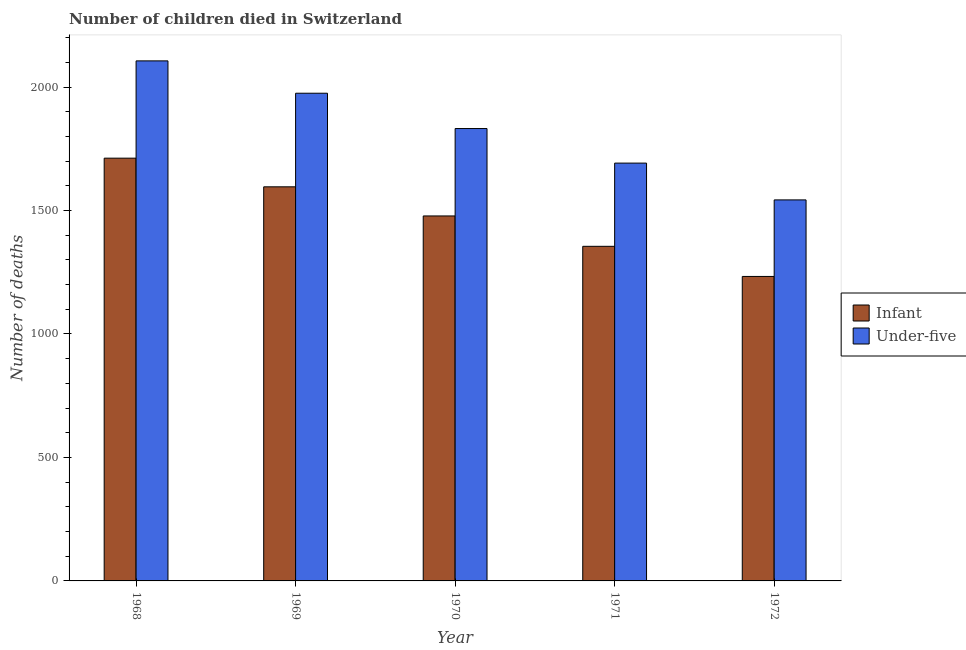How many different coloured bars are there?
Your answer should be very brief. 2. How many groups of bars are there?
Your response must be concise. 5. Are the number of bars per tick equal to the number of legend labels?
Ensure brevity in your answer.  Yes. Are the number of bars on each tick of the X-axis equal?
Keep it short and to the point. Yes. How many bars are there on the 1st tick from the left?
Your answer should be compact. 2. What is the number of infant deaths in 1969?
Offer a terse response. 1596. Across all years, what is the maximum number of under-five deaths?
Your answer should be compact. 2106. Across all years, what is the minimum number of under-five deaths?
Your answer should be very brief. 1543. In which year was the number of under-five deaths maximum?
Provide a succinct answer. 1968. What is the total number of under-five deaths in the graph?
Offer a very short reply. 9148. What is the difference between the number of infant deaths in 1968 and that in 1971?
Make the answer very short. 357. What is the difference between the number of under-five deaths in 1969 and the number of infant deaths in 1968?
Your answer should be compact. -131. What is the average number of under-five deaths per year?
Provide a short and direct response. 1829.6. What is the ratio of the number of under-five deaths in 1969 to that in 1970?
Keep it short and to the point. 1.08. What is the difference between the highest and the second highest number of infant deaths?
Your response must be concise. 116. What is the difference between the highest and the lowest number of infant deaths?
Give a very brief answer. 479. Is the sum of the number of under-five deaths in 1970 and 1972 greater than the maximum number of infant deaths across all years?
Make the answer very short. Yes. What does the 1st bar from the left in 1969 represents?
Your response must be concise. Infant. What does the 1st bar from the right in 1969 represents?
Your answer should be compact. Under-five. How many bars are there?
Ensure brevity in your answer.  10. Are all the bars in the graph horizontal?
Make the answer very short. No. How many years are there in the graph?
Provide a succinct answer. 5. What is the difference between two consecutive major ticks on the Y-axis?
Your answer should be compact. 500. Are the values on the major ticks of Y-axis written in scientific E-notation?
Offer a terse response. No. Does the graph contain grids?
Your answer should be compact. No. Where does the legend appear in the graph?
Your answer should be very brief. Center right. How are the legend labels stacked?
Make the answer very short. Vertical. What is the title of the graph?
Your answer should be very brief. Number of children died in Switzerland. Does "IMF nonconcessional" appear as one of the legend labels in the graph?
Make the answer very short. No. What is the label or title of the Y-axis?
Keep it short and to the point. Number of deaths. What is the Number of deaths in Infant in 1968?
Your answer should be very brief. 1712. What is the Number of deaths of Under-five in 1968?
Make the answer very short. 2106. What is the Number of deaths in Infant in 1969?
Make the answer very short. 1596. What is the Number of deaths in Under-five in 1969?
Your response must be concise. 1975. What is the Number of deaths in Infant in 1970?
Your response must be concise. 1478. What is the Number of deaths of Under-five in 1970?
Make the answer very short. 1832. What is the Number of deaths of Infant in 1971?
Your answer should be very brief. 1355. What is the Number of deaths in Under-five in 1971?
Ensure brevity in your answer.  1692. What is the Number of deaths of Infant in 1972?
Your answer should be very brief. 1233. What is the Number of deaths in Under-five in 1972?
Offer a terse response. 1543. Across all years, what is the maximum Number of deaths in Infant?
Ensure brevity in your answer.  1712. Across all years, what is the maximum Number of deaths in Under-five?
Ensure brevity in your answer.  2106. Across all years, what is the minimum Number of deaths of Infant?
Your answer should be very brief. 1233. Across all years, what is the minimum Number of deaths in Under-five?
Your answer should be compact. 1543. What is the total Number of deaths of Infant in the graph?
Give a very brief answer. 7374. What is the total Number of deaths in Under-five in the graph?
Offer a very short reply. 9148. What is the difference between the Number of deaths in Infant in 1968 and that in 1969?
Offer a terse response. 116. What is the difference between the Number of deaths in Under-five in 1968 and that in 1969?
Give a very brief answer. 131. What is the difference between the Number of deaths of Infant in 1968 and that in 1970?
Provide a short and direct response. 234. What is the difference between the Number of deaths of Under-five in 1968 and that in 1970?
Give a very brief answer. 274. What is the difference between the Number of deaths in Infant in 1968 and that in 1971?
Make the answer very short. 357. What is the difference between the Number of deaths of Under-five in 1968 and that in 1971?
Give a very brief answer. 414. What is the difference between the Number of deaths in Infant in 1968 and that in 1972?
Your response must be concise. 479. What is the difference between the Number of deaths in Under-five in 1968 and that in 1972?
Your answer should be very brief. 563. What is the difference between the Number of deaths in Infant in 1969 and that in 1970?
Your answer should be compact. 118. What is the difference between the Number of deaths in Under-five in 1969 and that in 1970?
Offer a terse response. 143. What is the difference between the Number of deaths in Infant in 1969 and that in 1971?
Offer a very short reply. 241. What is the difference between the Number of deaths of Under-five in 1969 and that in 1971?
Make the answer very short. 283. What is the difference between the Number of deaths of Infant in 1969 and that in 1972?
Offer a terse response. 363. What is the difference between the Number of deaths of Under-five in 1969 and that in 1972?
Provide a succinct answer. 432. What is the difference between the Number of deaths in Infant in 1970 and that in 1971?
Offer a very short reply. 123. What is the difference between the Number of deaths in Under-five in 1970 and that in 1971?
Your answer should be compact. 140. What is the difference between the Number of deaths of Infant in 1970 and that in 1972?
Offer a very short reply. 245. What is the difference between the Number of deaths of Under-five in 1970 and that in 1972?
Keep it short and to the point. 289. What is the difference between the Number of deaths in Infant in 1971 and that in 1972?
Make the answer very short. 122. What is the difference between the Number of deaths in Under-five in 1971 and that in 1972?
Provide a succinct answer. 149. What is the difference between the Number of deaths in Infant in 1968 and the Number of deaths in Under-five in 1969?
Provide a succinct answer. -263. What is the difference between the Number of deaths of Infant in 1968 and the Number of deaths of Under-five in 1970?
Your answer should be compact. -120. What is the difference between the Number of deaths of Infant in 1968 and the Number of deaths of Under-five in 1971?
Offer a terse response. 20. What is the difference between the Number of deaths in Infant in 1968 and the Number of deaths in Under-five in 1972?
Offer a very short reply. 169. What is the difference between the Number of deaths in Infant in 1969 and the Number of deaths in Under-five in 1970?
Give a very brief answer. -236. What is the difference between the Number of deaths in Infant in 1969 and the Number of deaths in Under-five in 1971?
Give a very brief answer. -96. What is the difference between the Number of deaths in Infant in 1969 and the Number of deaths in Under-five in 1972?
Offer a very short reply. 53. What is the difference between the Number of deaths of Infant in 1970 and the Number of deaths of Under-five in 1971?
Your answer should be compact. -214. What is the difference between the Number of deaths in Infant in 1970 and the Number of deaths in Under-five in 1972?
Your answer should be compact. -65. What is the difference between the Number of deaths of Infant in 1971 and the Number of deaths of Under-five in 1972?
Offer a terse response. -188. What is the average Number of deaths in Infant per year?
Give a very brief answer. 1474.8. What is the average Number of deaths of Under-five per year?
Make the answer very short. 1829.6. In the year 1968, what is the difference between the Number of deaths in Infant and Number of deaths in Under-five?
Your answer should be very brief. -394. In the year 1969, what is the difference between the Number of deaths in Infant and Number of deaths in Under-five?
Give a very brief answer. -379. In the year 1970, what is the difference between the Number of deaths in Infant and Number of deaths in Under-five?
Your answer should be very brief. -354. In the year 1971, what is the difference between the Number of deaths of Infant and Number of deaths of Under-five?
Make the answer very short. -337. In the year 1972, what is the difference between the Number of deaths in Infant and Number of deaths in Under-five?
Ensure brevity in your answer.  -310. What is the ratio of the Number of deaths of Infant in 1968 to that in 1969?
Offer a very short reply. 1.07. What is the ratio of the Number of deaths of Under-five in 1968 to that in 1969?
Offer a terse response. 1.07. What is the ratio of the Number of deaths of Infant in 1968 to that in 1970?
Make the answer very short. 1.16. What is the ratio of the Number of deaths of Under-five in 1968 to that in 1970?
Your answer should be compact. 1.15. What is the ratio of the Number of deaths of Infant in 1968 to that in 1971?
Your answer should be very brief. 1.26. What is the ratio of the Number of deaths of Under-five in 1968 to that in 1971?
Offer a terse response. 1.24. What is the ratio of the Number of deaths of Infant in 1968 to that in 1972?
Your answer should be very brief. 1.39. What is the ratio of the Number of deaths of Under-five in 1968 to that in 1972?
Make the answer very short. 1.36. What is the ratio of the Number of deaths in Infant in 1969 to that in 1970?
Your answer should be very brief. 1.08. What is the ratio of the Number of deaths in Under-five in 1969 to that in 1970?
Your answer should be compact. 1.08. What is the ratio of the Number of deaths of Infant in 1969 to that in 1971?
Offer a terse response. 1.18. What is the ratio of the Number of deaths in Under-five in 1969 to that in 1971?
Offer a very short reply. 1.17. What is the ratio of the Number of deaths in Infant in 1969 to that in 1972?
Provide a succinct answer. 1.29. What is the ratio of the Number of deaths in Under-five in 1969 to that in 1972?
Provide a short and direct response. 1.28. What is the ratio of the Number of deaths in Infant in 1970 to that in 1971?
Keep it short and to the point. 1.09. What is the ratio of the Number of deaths of Under-five in 1970 to that in 1971?
Keep it short and to the point. 1.08. What is the ratio of the Number of deaths of Infant in 1970 to that in 1972?
Keep it short and to the point. 1.2. What is the ratio of the Number of deaths in Under-five in 1970 to that in 1972?
Offer a very short reply. 1.19. What is the ratio of the Number of deaths of Infant in 1971 to that in 1972?
Give a very brief answer. 1.1. What is the ratio of the Number of deaths in Under-five in 1971 to that in 1972?
Offer a very short reply. 1.1. What is the difference between the highest and the second highest Number of deaths of Infant?
Provide a short and direct response. 116. What is the difference between the highest and the second highest Number of deaths of Under-five?
Make the answer very short. 131. What is the difference between the highest and the lowest Number of deaths of Infant?
Offer a very short reply. 479. What is the difference between the highest and the lowest Number of deaths of Under-five?
Your answer should be compact. 563. 